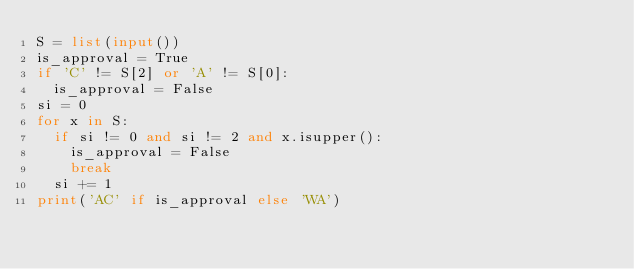<code> <loc_0><loc_0><loc_500><loc_500><_Python_>S = list(input())
is_approval = True
if 'C' != S[2] or 'A' != S[0]:
  is_approval = False
si = 0
for x in S:
  if si != 0 and si != 2 and x.isupper():
    is_approval = False
    break
  si += 1
print('AC' if is_approval else 'WA')</code> 